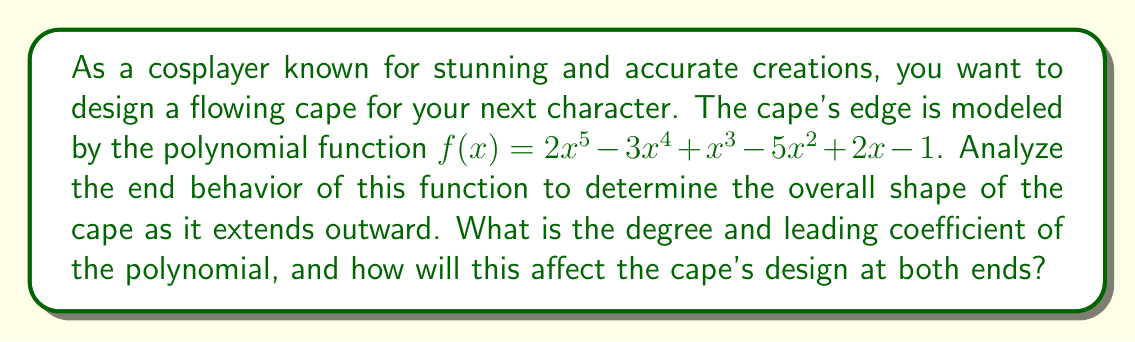Solve this math problem. To analyze the end behavior of the polynomial function and determine its impact on the cape design, we need to follow these steps:

1. Identify the degree of the polynomial:
   The degree is the highest power of x in the polynomial. In this case, the highest power is 5, so the degree is 5.

2. Identify the leading coefficient:
   The leading coefficient is the coefficient of the term with the highest degree. Here, it's 2.

3. Determine the end behavior:
   For odd-degree polynomials (like this one), the end behavior depends on the sign of the leading coefficient:
   - If the leading coefficient is positive, as x approaches positive infinity, f(x) approaches positive infinity, and as x approaches negative infinity, f(x) approaches negative infinity.
   - If the leading coefficient is negative, the behavior would be opposite.

   In this case, the leading coefficient is 2 (positive), so:
   $$\lim_{x \to +\infty} f(x) = +\infty$$
   $$\lim_{x \to -\infty} f(x) = -\infty$$

4. Interpret the results for cape design:
   - As x increases (moving right), the cape will curve upward dramatically.
   - As x decreases (moving left), the cape will curve downward dramatically.
   - The cape will have a sweeping, asymmetrical design that rises on one side and falls on the other.

The high degree (5) means the cape will have a more dramatic and curved shape compared to lower-degree polynomials. The positive leading coefficient (2) ensures the right side of the cape will sweep upward, creating a dynamic and flowing appearance.
Answer: The polynomial has a degree of 5 and a leading coefficient of 2. This will result in a cape design that dramatically curves upward on the right side and downward on the left side, creating a sweeping, asymmetrical, and flowing appearance. 